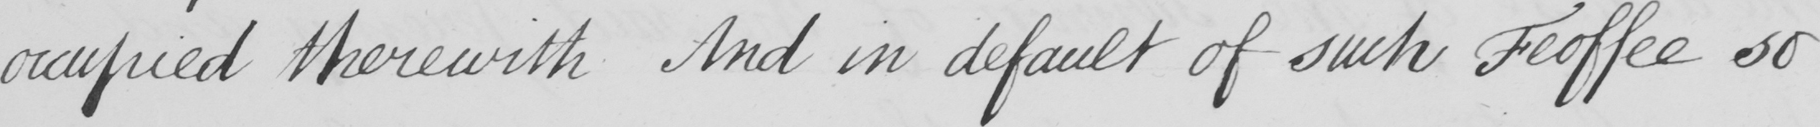What is written in this line of handwriting? occupied therewith And in default of such Feoffee so 